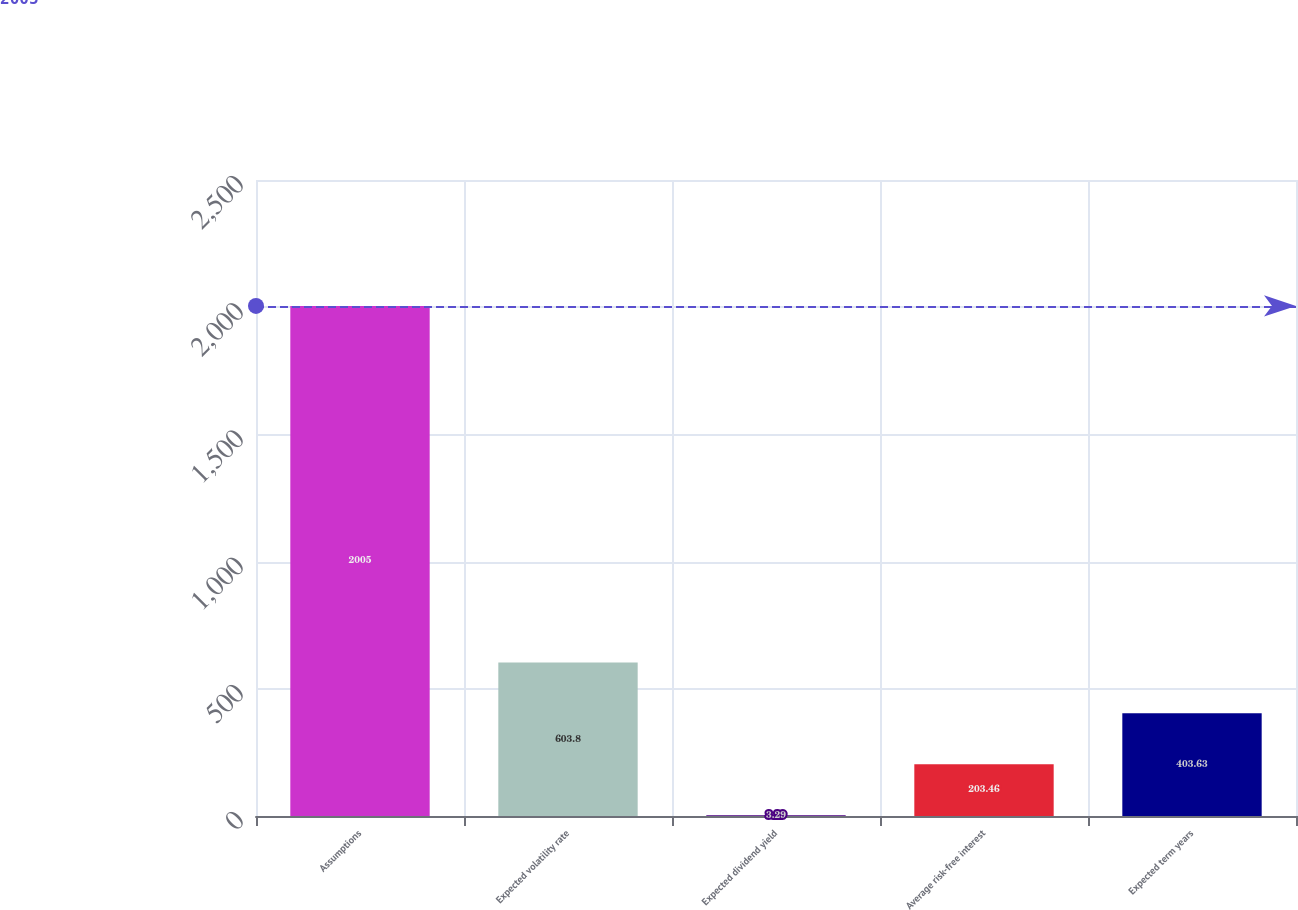Convert chart to OTSL. <chart><loc_0><loc_0><loc_500><loc_500><bar_chart><fcel>Assumptions<fcel>Expected volatility rate<fcel>Expected dividend yield<fcel>Average risk-free interest<fcel>Expected term years<nl><fcel>2005<fcel>603.8<fcel>3.29<fcel>203.46<fcel>403.63<nl></chart> 